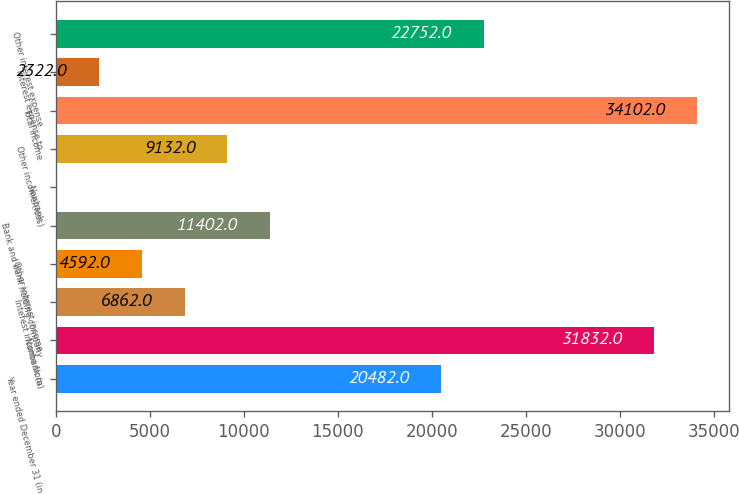Convert chart. <chart><loc_0><loc_0><loc_500><loc_500><bar_chart><fcel>Year ended December 31 (in<fcel>Nonbank (a)<fcel>Interest income from<fcel>Other interest income<fcel>Bank and bank holding company<fcel>Nonbank<fcel>Other income/(loss)<fcel>Total income<fcel>Interest expense to<fcel>Other interest expense<nl><fcel>20482<fcel>31832<fcel>6862<fcel>4592<fcel>11402<fcel>52<fcel>9132<fcel>34102<fcel>2322<fcel>22752<nl></chart> 